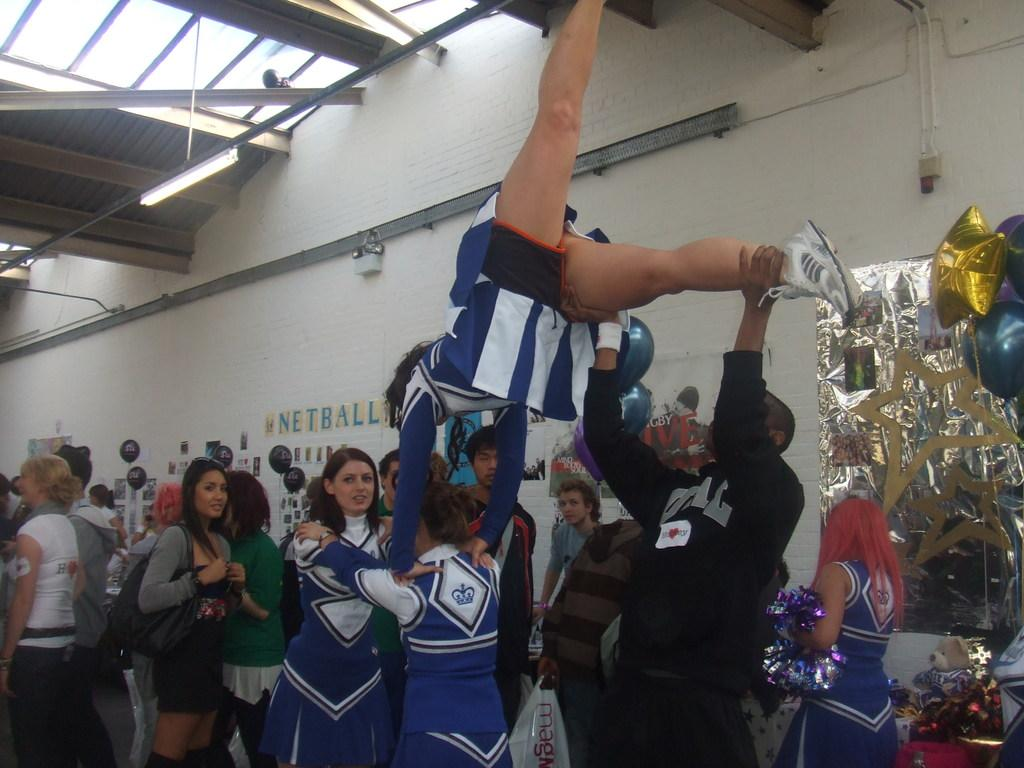<image>
Write a terse but informative summary of the picture. Cheerleaders do stunts in front of a wall with the word 'Netball' on it. 